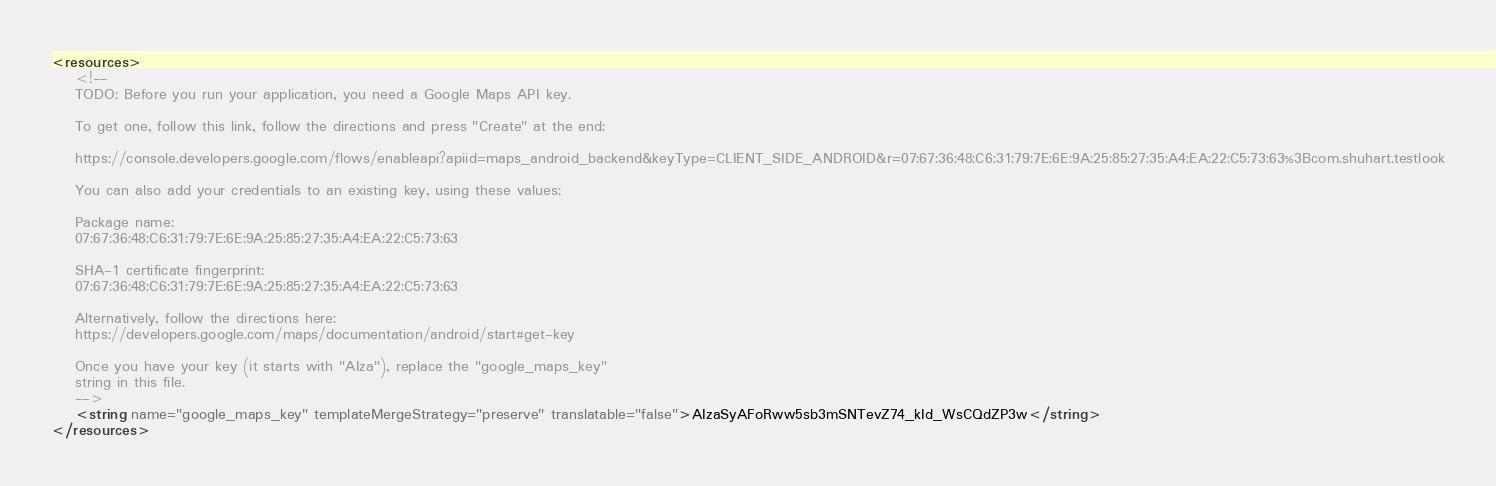Convert code to text. <code><loc_0><loc_0><loc_500><loc_500><_XML_><resources>
    <!--
    TODO: Before you run your application, you need a Google Maps API key.

    To get one, follow this link, follow the directions and press "Create" at the end:

    https://console.developers.google.com/flows/enableapi?apiid=maps_android_backend&keyType=CLIENT_SIDE_ANDROID&r=07:67:36:48:C6:31:79:7E:6E:9A:25:85:27:35:A4:EA:22:C5:73:63%3Bcom.shuhart.testlook

    You can also add your credentials to an existing key, using these values:

    Package name:
    07:67:36:48:C6:31:79:7E:6E:9A:25:85:27:35:A4:EA:22:C5:73:63

    SHA-1 certificate fingerprint:
    07:67:36:48:C6:31:79:7E:6E:9A:25:85:27:35:A4:EA:22:C5:73:63

    Alternatively, follow the directions here:
    https://developers.google.com/maps/documentation/android/start#get-key

    Once you have your key (it starts with "AIza"), replace the "google_maps_key"
    string in this file.
    -->
    <string name="google_maps_key" templateMergeStrategy="preserve" translatable="false">AIzaSyAFoRww5sb3mSNTevZ74_kId_WsCQdZP3w</string>
</resources>
</code> 